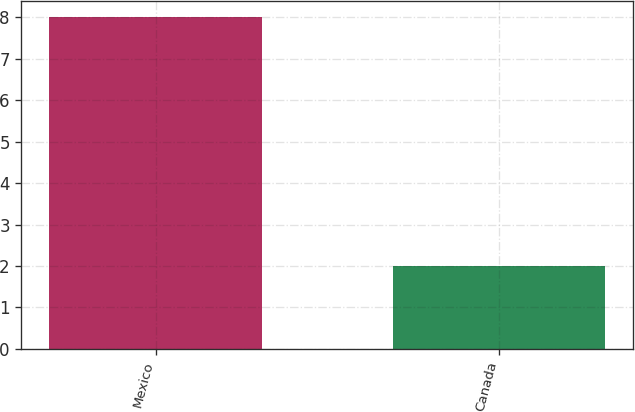Convert chart. <chart><loc_0><loc_0><loc_500><loc_500><bar_chart><fcel>Mexico<fcel>Canada<nl><fcel>8<fcel>2<nl></chart> 